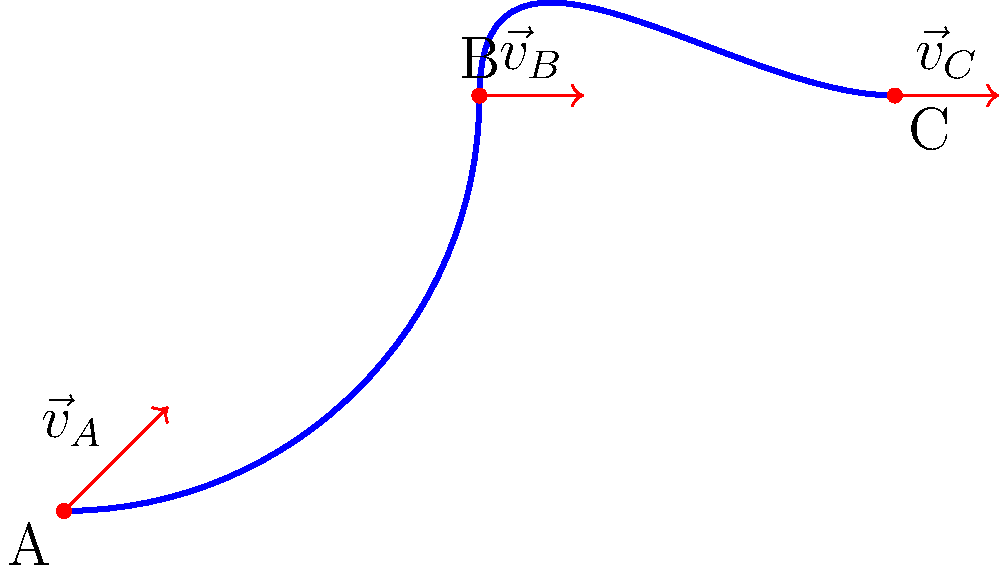A Latvian bobsled team is practicing on a curved track as shown in the diagram. The velocity vectors at points A, B, and C are represented by red arrows. If the magnitude of velocity at point A is 20 m/s, and the bobsled maintains constant speed throughout the track, calculate the components of the velocity vector at point B $(v_{Bx}, v_{By})$. Let's approach this step-by-step:

1) First, we need to understand that while the speed (magnitude of velocity) remains constant, the direction of the velocity vector changes due to the curved track.

2) At point A, the bobsled is moving along a 45° angle. We can represent this velocity as:

   $\vec{v}_A = (v_{Ax}, v_{Ay}) = (20\cos45°, 20\sin45°) = (20 \cdot \frac{\sqrt{2}}{2}, 20 \cdot \frac{\sqrt{2}}{2}) \approx (14.14, 14.14)$ m/s

3) At point B, the track is horizontal, so the velocity vector will be purely in the x-direction.

4) Since the speed remains constant, the magnitude of $\vec{v}_B$ must equal the magnitude of $\vec{v}_A$, which is 20 m/s.

5) Therefore, at point B:

   $\vec{v}_B = (v_{Bx}, v_{By}) = (20, 0)$ m/s

This means the bobsled is moving horizontally to the right with a speed of 20 m/s at point B.
Answer: $(20, 0)$ m/s 